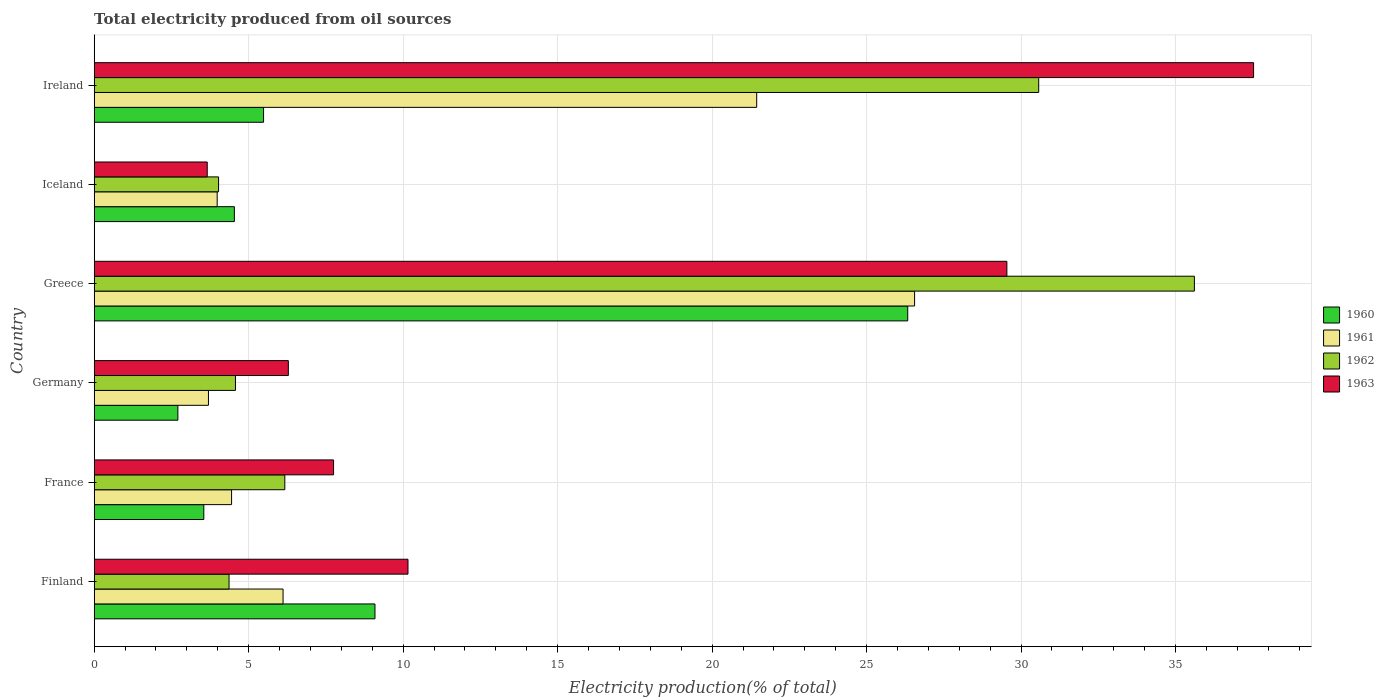How many different coloured bars are there?
Ensure brevity in your answer.  4. Are the number of bars per tick equal to the number of legend labels?
Your response must be concise. Yes. In how many cases, is the number of bars for a given country not equal to the number of legend labels?
Give a very brief answer. 0. What is the total electricity produced in 1960 in France?
Give a very brief answer. 3.55. Across all countries, what is the maximum total electricity produced in 1960?
Keep it short and to the point. 26.33. Across all countries, what is the minimum total electricity produced in 1963?
Provide a short and direct response. 3.66. In which country was the total electricity produced in 1961 maximum?
Provide a succinct answer. Greece. In which country was the total electricity produced in 1963 minimum?
Make the answer very short. Iceland. What is the total total electricity produced in 1961 in the graph?
Give a very brief answer. 66.23. What is the difference between the total electricity produced in 1963 in Finland and that in Iceland?
Provide a succinct answer. 6.5. What is the difference between the total electricity produced in 1962 in Greece and the total electricity produced in 1961 in Germany?
Keep it short and to the point. 31.91. What is the average total electricity produced in 1963 per country?
Make the answer very short. 15.82. What is the difference between the total electricity produced in 1960 and total electricity produced in 1961 in Greece?
Ensure brevity in your answer.  -0.22. What is the ratio of the total electricity produced in 1963 in Finland to that in Germany?
Your answer should be compact. 1.62. What is the difference between the highest and the second highest total electricity produced in 1963?
Ensure brevity in your answer.  7.99. What is the difference between the highest and the lowest total electricity produced in 1962?
Give a very brief answer. 31.58. Is the sum of the total electricity produced in 1962 in Finland and Ireland greater than the maximum total electricity produced in 1963 across all countries?
Offer a very short reply. No. What does the 4th bar from the top in France represents?
Your answer should be compact. 1960. What does the 1st bar from the bottom in France represents?
Your answer should be compact. 1960. Are all the bars in the graph horizontal?
Provide a short and direct response. Yes. How many countries are there in the graph?
Your response must be concise. 6. Where does the legend appear in the graph?
Keep it short and to the point. Center right. How many legend labels are there?
Your response must be concise. 4. How are the legend labels stacked?
Offer a terse response. Vertical. What is the title of the graph?
Offer a terse response. Total electricity produced from oil sources. What is the label or title of the Y-axis?
Make the answer very short. Country. What is the Electricity production(% of total) of 1960 in Finland?
Ensure brevity in your answer.  9.09. What is the Electricity production(% of total) in 1961 in Finland?
Offer a very short reply. 6.11. What is the Electricity production(% of total) in 1962 in Finland?
Give a very brief answer. 4.36. What is the Electricity production(% of total) of 1963 in Finland?
Ensure brevity in your answer.  10.16. What is the Electricity production(% of total) in 1960 in France?
Provide a short and direct response. 3.55. What is the Electricity production(% of total) in 1961 in France?
Offer a very short reply. 4.45. What is the Electricity production(% of total) in 1962 in France?
Ensure brevity in your answer.  6.17. What is the Electricity production(% of total) of 1963 in France?
Your response must be concise. 7.75. What is the Electricity production(% of total) of 1960 in Germany?
Make the answer very short. 2.71. What is the Electricity production(% of total) in 1961 in Germany?
Give a very brief answer. 3.7. What is the Electricity production(% of total) in 1962 in Germany?
Keep it short and to the point. 4.57. What is the Electricity production(% of total) in 1963 in Germany?
Offer a terse response. 6.28. What is the Electricity production(% of total) in 1960 in Greece?
Provide a succinct answer. 26.33. What is the Electricity production(% of total) in 1961 in Greece?
Your answer should be very brief. 26.55. What is the Electricity production(% of total) in 1962 in Greece?
Provide a succinct answer. 35.61. What is the Electricity production(% of total) of 1963 in Greece?
Keep it short and to the point. 29.54. What is the Electricity production(% of total) of 1960 in Iceland?
Your answer should be very brief. 4.54. What is the Electricity production(% of total) of 1961 in Iceland?
Ensure brevity in your answer.  3.98. What is the Electricity production(% of total) in 1962 in Iceland?
Provide a short and direct response. 4.03. What is the Electricity production(% of total) in 1963 in Iceland?
Your response must be concise. 3.66. What is the Electricity production(% of total) of 1960 in Ireland?
Your answer should be compact. 5.48. What is the Electricity production(% of total) in 1961 in Ireland?
Provide a short and direct response. 21.44. What is the Electricity production(% of total) of 1962 in Ireland?
Keep it short and to the point. 30.57. What is the Electricity production(% of total) of 1963 in Ireland?
Provide a succinct answer. 37.53. Across all countries, what is the maximum Electricity production(% of total) of 1960?
Offer a very short reply. 26.33. Across all countries, what is the maximum Electricity production(% of total) in 1961?
Offer a very short reply. 26.55. Across all countries, what is the maximum Electricity production(% of total) in 1962?
Make the answer very short. 35.61. Across all countries, what is the maximum Electricity production(% of total) of 1963?
Offer a terse response. 37.53. Across all countries, what is the minimum Electricity production(% of total) of 1960?
Provide a short and direct response. 2.71. Across all countries, what is the minimum Electricity production(% of total) in 1961?
Make the answer very short. 3.7. Across all countries, what is the minimum Electricity production(% of total) of 1962?
Your response must be concise. 4.03. Across all countries, what is the minimum Electricity production(% of total) in 1963?
Keep it short and to the point. 3.66. What is the total Electricity production(% of total) in 1960 in the graph?
Provide a short and direct response. 51.7. What is the total Electricity production(% of total) in 1961 in the graph?
Your answer should be very brief. 66.23. What is the total Electricity production(% of total) in 1962 in the graph?
Give a very brief answer. 85.31. What is the total Electricity production(% of total) of 1963 in the graph?
Your answer should be compact. 94.91. What is the difference between the Electricity production(% of total) in 1960 in Finland and that in France?
Keep it short and to the point. 5.54. What is the difference between the Electricity production(% of total) in 1961 in Finland and that in France?
Your response must be concise. 1.67. What is the difference between the Electricity production(% of total) in 1962 in Finland and that in France?
Your answer should be compact. -1.8. What is the difference between the Electricity production(% of total) in 1963 in Finland and that in France?
Offer a very short reply. 2.41. What is the difference between the Electricity production(% of total) in 1960 in Finland and that in Germany?
Offer a terse response. 6.38. What is the difference between the Electricity production(% of total) of 1961 in Finland and that in Germany?
Your response must be concise. 2.41. What is the difference between the Electricity production(% of total) of 1962 in Finland and that in Germany?
Ensure brevity in your answer.  -0.21. What is the difference between the Electricity production(% of total) in 1963 in Finland and that in Germany?
Ensure brevity in your answer.  3.87. What is the difference between the Electricity production(% of total) of 1960 in Finland and that in Greece?
Keep it short and to the point. -17.24. What is the difference between the Electricity production(% of total) in 1961 in Finland and that in Greece?
Offer a very short reply. -20.44. What is the difference between the Electricity production(% of total) in 1962 in Finland and that in Greece?
Your response must be concise. -31.25. What is the difference between the Electricity production(% of total) in 1963 in Finland and that in Greece?
Give a very brief answer. -19.38. What is the difference between the Electricity production(% of total) in 1960 in Finland and that in Iceland?
Your answer should be compact. 4.55. What is the difference between the Electricity production(% of total) in 1961 in Finland and that in Iceland?
Give a very brief answer. 2.13. What is the difference between the Electricity production(% of total) in 1962 in Finland and that in Iceland?
Ensure brevity in your answer.  0.34. What is the difference between the Electricity production(% of total) in 1963 in Finland and that in Iceland?
Offer a terse response. 6.5. What is the difference between the Electricity production(% of total) of 1960 in Finland and that in Ireland?
Ensure brevity in your answer.  3.61. What is the difference between the Electricity production(% of total) of 1961 in Finland and that in Ireland?
Make the answer very short. -15.33. What is the difference between the Electricity production(% of total) of 1962 in Finland and that in Ireland?
Ensure brevity in your answer.  -26.21. What is the difference between the Electricity production(% of total) of 1963 in Finland and that in Ireland?
Provide a short and direct response. -27.37. What is the difference between the Electricity production(% of total) in 1960 in France and that in Germany?
Your answer should be very brief. 0.84. What is the difference between the Electricity production(% of total) in 1961 in France and that in Germany?
Your response must be concise. 0.75. What is the difference between the Electricity production(% of total) in 1962 in France and that in Germany?
Your answer should be very brief. 1.6. What is the difference between the Electricity production(% of total) of 1963 in France and that in Germany?
Provide a succinct answer. 1.46. What is the difference between the Electricity production(% of total) of 1960 in France and that in Greece?
Your answer should be very brief. -22.78. What is the difference between the Electricity production(% of total) in 1961 in France and that in Greece?
Your response must be concise. -22.11. What is the difference between the Electricity production(% of total) of 1962 in France and that in Greece?
Offer a very short reply. -29.44. What is the difference between the Electricity production(% of total) in 1963 in France and that in Greece?
Keep it short and to the point. -21.79. What is the difference between the Electricity production(% of total) in 1960 in France and that in Iceland?
Provide a short and direct response. -0.99. What is the difference between the Electricity production(% of total) in 1961 in France and that in Iceland?
Offer a very short reply. 0.47. What is the difference between the Electricity production(% of total) in 1962 in France and that in Iceland?
Offer a terse response. 2.14. What is the difference between the Electricity production(% of total) in 1963 in France and that in Iceland?
Your response must be concise. 4.09. What is the difference between the Electricity production(% of total) of 1960 in France and that in Ireland?
Your answer should be very brief. -1.93. What is the difference between the Electricity production(% of total) of 1961 in France and that in Ireland?
Your answer should be compact. -17. What is the difference between the Electricity production(% of total) in 1962 in France and that in Ireland?
Your answer should be very brief. -24.4. What is the difference between the Electricity production(% of total) in 1963 in France and that in Ireland?
Give a very brief answer. -29.78. What is the difference between the Electricity production(% of total) in 1960 in Germany and that in Greece?
Provide a succinct answer. -23.62. What is the difference between the Electricity production(% of total) in 1961 in Germany and that in Greece?
Ensure brevity in your answer.  -22.86. What is the difference between the Electricity production(% of total) of 1962 in Germany and that in Greece?
Your answer should be very brief. -31.04. What is the difference between the Electricity production(% of total) in 1963 in Germany and that in Greece?
Offer a terse response. -23.26. What is the difference between the Electricity production(% of total) in 1960 in Germany and that in Iceland?
Offer a terse response. -1.83. What is the difference between the Electricity production(% of total) of 1961 in Germany and that in Iceland?
Your answer should be very brief. -0.28. What is the difference between the Electricity production(% of total) of 1962 in Germany and that in Iceland?
Ensure brevity in your answer.  0.55. What is the difference between the Electricity production(% of total) of 1963 in Germany and that in Iceland?
Your response must be concise. 2.63. What is the difference between the Electricity production(% of total) in 1960 in Germany and that in Ireland?
Your answer should be very brief. -2.77. What is the difference between the Electricity production(% of total) of 1961 in Germany and that in Ireland?
Give a very brief answer. -17.75. What is the difference between the Electricity production(% of total) in 1962 in Germany and that in Ireland?
Offer a terse response. -26. What is the difference between the Electricity production(% of total) of 1963 in Germany and that in Ireland?
Offer a very short reply. -31.24. What is the difference between the Electricity production(% of total) of 1960 in Greece and that in Iceland?
Make the answer very short. 21.79. What is the difference between the Electricity production(% of total) in 1961 in Greece and that in Iceland?
Your answer should be compact. 22.57. What is the difference between the Electricity production(% of total) of 1962 in Greece and that in Iceland?
Offer a terse response. 31.58. What is the difference between the Electricity production(% of total) of 1963 in Greece and that in Iceland?
Offer a very short reply. 25.88. What is the difference between the Electricity production(% of total) of 1960 in Greece and that in Ireland?
Your response must be concise. 20.85. What is the difference between the Electricity production(% of total) of 1961 in Greece and that in Ireland?
Your answer should be very brief. 5.11. What is the difference between the Electricity production(% of total) in 1962 in Greece and that in Ireland?
Ensure brevity in your answer.  5.04. What is the difference between the Electricity production(% of total) in 1963 in Greece and that in Ireland?
Make the answer very short. -7.99. What is the difference between the Electricity production(% of total) of 1960 in Iceland and that in Ireland?
Make the answer very short. -0.94. What is the difference between the Electricity production(% of total) in 1961 in Iceland and that in Ireland?
Offer a very short reply. -17.46. What is the difference between the Electricity production(% of total) of 1962 in Iceland and that in Ireland?
Keep it short and to the point. -26.55. What is the difference between the Electricity production(% of total) in 1963 in Iceland and that in Ireland?
Your answer should be very brief. -33.87. What is the difference between the Electricity production(% of total) in 1960 in Finland and the Electricity production(% of total) in 1961 in France?
Your response must be concise. 4.64. What is the difference between the Electricity production(% of total) in 1960 in Finland and the Electricity production(% of total) in 1962 in France?
Offer a terse response. 2.92. What is the difference between the Electricity production(% of total) of 1960 in Finland and the Electricity production(% of total) of 1963 in France?
Keep it short and to the point. 1.34. What is the difference between the Electricity production(% of total) of 1961 in Finland and the Electricity production(% of total) of 1962 in France?
Offer a very short reply. -0.06. What is the difference between the Electricity production(% of total) in 1961 in Finland and the Electricity production(% of total) in 1963 in France?
Give a very brief answer. -1.64. What is the difference between the Electricity production(% of total) in 1962 in Finland and the Electricity production(% of total) in 1963 in France?
Your answer should be compact. -3.38. What is the difference between the Electricity production(% of total) of 1960 in Finland and the Electricity production(% of total) of 1961 in Germany?
Make the answer very short. 5.39. What is the difference between the Electricity production(% of total) of 1960 in Finland and the Electricity production(% of total) of 1962 in Germany?
Provide a short and direct response. 4.51. What is the difference between the Electricity production(% of total) of 1960 in Finland and the Electricity production(% of total) of 1963 in Germany?
Keep it short and to the point. 2.8. What is the difference between the Electricity production(% of total) of 1961 in Finland and the Electricity production(% of total) of 1962 in Germany?
Offer a very short reply. 1.54. What is the difference between the Electricity production(% of total) of 1961 in Finland and the Electricity production(% of total) of 1963 in Germany?
Offer a very short reply. -0.17. What is the difference between the Electricity production(% of total) in 1962 in Finland and the Electricity production(% of total) in 1963 in Germany?
Offer a very short reply. -1.92. What is the difference between the Electricity production(% of total) of 1960 in Finland and the Electricity production(% of total) of 1961 in Greece?
Offer a very short reply. -17.47. What is the difference between the Electricity production(% of total) of 1960 in Finland and the Electricity production(% of total) of 1962 in Greece?
Your answer should be very brief. -26.52. What is the difference between the Electricity production(% of total) of 1960 in Finland and the Electricity production(% of total) of 1963 in Greece?
Provide a short and direct response. -20.45. What is the difference between the Electricity production(% of total) in 1961 in Finland and the Electricity production(% of total) in 1962 in Greece?
Offer a terse response. -29.5. What is the difference between the Electricity production(% of total) in 1961 in Finland and the Electricity production(% of total) in 1963 in Greece?
Your answer should be compact. -23.43. What is the difference between the Electricity production(% of total) of 1962 in Finland and the Electricity production(% of total) of 1963 in Greece?
Ensure brevity in your answer.  -25.18. What is the difference between the Electricity production(% of total) of 1960 in Finland and the Electricity production(% of total) of 1961 in Iceland?
Give a very brief answer. 5.11. What is the difference between the Electricity production(% of total) in 1960 in Finland and the Electricity production(% of total) in 1962 in Iceland?
Your answer should be compact. 5.06. What is the difference between the Electricity production(% of total) in 1960 in Finland and the Electricity production(% of total) in 1963 in Iceland?
Your answer should be compact. 5.43. What is the difference between the Electricity production(% of total) in 1961 in Finland and the Electricity production(% of total) in 1962 in Iceland?
Keep it short and to the point. 2.09. What is the difference between the Electricity production(% of total) in 1961 in Finland and the Electricity production(% of total) in 1963 in Iceland?
Provide a succinct answer. 2.45. What is the difference between the Electricity production(% of total) in 1962 in Finland and the Electricity production(% of total) in 1963 in Iceland?
Offer a very short reply. 0.71. What is the difference between the Electricity production(% of total) in 1960 in Finland and the Electricity production(% of total) in 1961 in Ireland?
Ensure brevity in your answer.  -12.36. What is the difference between the Electricity production(% of total) of 1960 in Finland and the Electricity production(% of total) of 1962 in Ireland?
Offer a very short reply. -21.48. What is the difference between the Electricity production(% of total) of 1960 in Finland and the Electricity production(% of total) of 1963 in Ireland?
Offer a terse response. -28.44. What is the difference between the Electricity production(% of total) in 1961 in Finland and the Electricity production(% of total) in 1962 in Ireland?
Offer a terse response. -24.46. What is the difference between the Electricity production(% of total) of 1961 in Finland and the Electricity production(% of total) of 1963 in Ireland?
Offer a very short reply. -31.41. What is the difference between the Electricity production(% of total) of 1962 in Finland and the Electricity production(% of total) of 1963 in Ireland?
Give a very brief answer. -33.16. What is the difference between the Electricity production(% of total) of 1960 in France and the Electricity production(% of total) of 1961 in Germany?
Ensure brevity in your answer.  -0.15. What is the difference between the Electricity production(% of total) of 1960 in France and the Electricity production(% of total) of 1962 in Germany?
Your answer should be compact. -1.02. What is the difference between the Electricity production(% of total) in 1960 in France and the Electricity production(% of total) in 1963 in Germany?
Provide a short and direct response. -2.74. What is the difference between the Electricity production(% of total) in 1961 in France and the Electricity production(% of total) in 1962 in Germany?
Offer a terse response. -0.13. What is the difference between the Electricity production(% of total) of 1961 in France and the Electricity production(% of total) of 1963 in Germany?
Make the answer very short. -1.84. What is the difference between the Electricity production(% of total) of 1962 in France and the Electricity production(% of total) of 1963 in Germany?
Your response must be concise. -0.11. What is the difference between the Electricity production(% of total) in 1960 in France and the Electricity production(% of total) in 1961 in Greece?
Your answer should be compact. -23.01. What is the difference between the Electricity production(% of total) of 1960 in France and the Electricity production(% of total) of 1962 in Greece?
Provide a short and direct response. -32.06. What is the difference between the Electricity production(% of total) of 1960 in France and the Electricity production(% of total) of 1963 in Greece?
Keep it short and to the point. -25.99. What is the difference between the Electricity production(% of total) in 1961 in France and the Electricity production(% of total) in 1962 in Greece?
Offer a terse response. -31.16. What is the difference between the Electricity production(% of total) in 1961 in France and the Electricity production(% of total) in 1963 in Greece?
Provide a short and direct response. -25.09. What is the difference between the Electricity production(% of total) of 1962 in France and the Electricity production(% of total) of 1963 in Greece?
Provide a succinct answer. -23.37. What is the difference between the Electricity production(% of total) of 1960 in France and the Electricity production(% of total) of 1961 in Iceland?
Offer a very short reply. -0.43. What is the difference between the Electricity production(% of total) of 1960 in France and the Electricity production(% of total) of 1962 in Iceland?
Ensure brevity in your answer.  -0.48. What is the difference between the Electricity production(% of total) of 1960 in France and the Electricity production(% of total) of 1963 in Iceland?
Your answer should be compact. -0.11. What is the difference between the Electricity production(% of total) of 1961 in France and the Electricity production(% of total) of 1962 in Iceland?
Keep it short and to the point. 0.42. What is the difference between the Electricity production(% of total) of 1961 in France and the Electricity production(% of total) of 1963 in Iceland?
Ensure brevity in your answer.  0.79. What is the difference between the Electricity production(% of total) of 1962 in France and the Electricity production(% of total) of 1963 in Iceland?
Make the answer very short. 2.51. What is the difference between the Electricity production(% of total) in 1960 in France and the Electricity production(% of total) in 1961 in Ireland?
Give a very brief answer. -17.9. What is the difference between the Electricity production(% of total) of 1960 in France and the Electricity production(% of total) of 1962 in Ireland?
Offer a terse response. -27.02. What is the difference between the Electricity production(% of total) in 1960 in France and the Electricity production(% of total) in 1963 in Ireland?
Keep it short and to the point. -33.98. What is the difference between the Electricity production(% of total) of 1961 in France and the Electricity production(% of total) of 1962 in Ireland?
Provide a short and direct response. -26.12. What is the difference between the Electricity production(% of total) in 1961 in France and the Electricity production(% of total) in 1963 in Ireland?
Your answer should be very brief. -33.08. What is the difference between the Electricity production(% of total) of 1962 in France and the Electricity production(% of total) of 1963 in Ireland?
Offer a very short reply. -31.36. What is the difference between the Electricity production(% of total) of 1960 in Germany and the Electricity production(% of total) of 1961 in Greece?
Keep it short and to the point. -23.85. What is the difference between the Electricity production(% of total) of 1960 in Germany and the Electricity production(% of total) of 1962 in Greece?
Your answer should be very brief. -32.9. What is the difference between the Electricity production(% of total) of 1960 in Germany and the Electricity production(% of total) of 1963 in Greece?
Your answer should be very brief. -26.83. What is the difference between the Electricity production(% of total) in 1961 in Germany and the Electricity production(% of total) in 1962 in Greece?
Your answer should be very brief. -31.91. What is the difference between the Electricity production(% of total) of 1961 in Germany and the Electricity production(% of total) of 1963 in Greece?
Give a very brief answer. -25.84. What is the difference between the Electricity production(% of total) of 1962 in Germany and the Electricity production(% of total) of 1963 in Greece?
Make the answer very short. -24.97. What is the difference between the Electricity production(% of total) of 1960 in Germany and the Electricity production(% of total) of 1961 in Iceland?
Your answer should be very brief. -1.27. What is the difference between the Electricity production(% of total) in 1960 in Germany and the Electricity production(% of total) in 1962 in Iceland?
Provide a short and direct response. -1.32. What is the difference between the Electricity production(% of total) of 1960 in Germany and the Electricity production(% of total) of 1963 in Iceland?
Provide a succinct answer. -0.95. What is the difference between the Electricity production(% of total) in 1961 in Germany and the Electricity production(% of total) in 1962 in Iceland?
Offer a very short reply. -0.33. What is the difference between the Electricity production(% of total) of 1961 in Germany and the Electricity production(% of total) of 1963 in Iceland?
Make the answer very short. 0.04. What is the difference between the Electricity production(% of total) of 1962 in Germany and the Electricity production(% of total) of 1963 in Iceland?
Provide a succinct answer. 0.91. What is the difference between the Electricity production(% of total) in 1960 in Germany and the Electricity production(% of total) in 1961 in Ireland?
Offer a very short reply. -18.73. What is the difference between the Electricity production(% of total) of 1960 in Germany and the Electricity production(% of total) of 1962 in Ireland?
Offer a terse response. -27.86. What is the difference between the Electricity production(% of total) in 1960 in Germany and the Electricity production(% of total) in 1963 in Ireland?
Keep it short and to the point. -34.82. What is the difference between the Electricity production(% of total) in 1961 in Germany and the Electricity production(% of total) in 1962 in Ireland?
Provide a short and direct response. -26.87. What is the difference between the Electricity production(% of total) of 1961 in Germany and the Electricity production(% of total) of 1963 in Ireland?
Offer a very short reply. -33.83. What is the difference between the Electricity production(% of total) of 1962 in Germany and the Electricity production(% of total) of 1963 in Ireland?
Provide a short and direct response. -32.95. What is the difference between the Electricity production(% of total) in 1960 in Greece and the Electricity production(% of total) in 1961 in Iceland?
Your answer should be compact. 22.35. What is the difference between the Electricity production(% of total) of 1960 in Greece and the Electricity production(% of total) of 1962 in Iceland?
Offer a terse response. 22.31. What is the difference between the Electricity production(% of total) of 1960 in Greece and the Electricity production(% of total) of 1963 in Iceland?
Offer a terse response. 22.67. What is the difference between the Electricity production(% of total) of 1961 in Greece and the Electricity production(% of total) of 1962 in Iceland?
Give a very brief answer. 22.53. What is the difference between the Electricity production(% of total) of 1961 in Greece and the Electricity production(% of total) of 1963 in Iceland?
Your response must be concise. 22.9. What is the difference between the Electricity production(% of total) in 1962 in Greece and the Electricity production(% of total) in 1963 in Iceland?
Your answer should be very brief. 31.95. What is the difference between the Electricity production(% of total) in 1960 in Greece and the Electricity production(% of total) in 1961 in Ireland?
Provide a short and direct response. 4.89. What is the difference between the Electricity production(% of total) of 1960 in Greece and the Electricity production(% of total) of 1962 in Ireland?
Your answer should be compact. -4.24. What is the difference between the Electricity production(% of total) in 1960 in Greece and the Electricity production(% of total) in 1963 in Ireland?
Make the answer very short. -11.19. What is the difference between the Electricity production(% of total) of 1961 in Greece and the Electricity production(% of total) of 1962 in Ireland?
Offer a terse response. -4.02. What is the difference between the Electricity production(% of total) in 1961 in Greece and the Electricity production(% of total) in 1963 in Ireland?
Provide a short and direct response. -10.97. What is the difference between the Electricity production(% of total) of 1962 in Greece and the Electricity production(% of total) of 1963 in Ireland?
Offer a very short reply. -1.92. What is the difference between the Electricity production(% of total) in 1960 in Iceland and the Electricity production(% of total) in 1961 in Ireland?
Your answer should be compact. -16.91. What is the difference between the Electricity production(% of total) in 1960 in Iceland and the Electricity production(% of total) in 1962 in Ireland?
Your answer should be very brief. -26.03. What is the difference between the Electricity production(% of total) in 1960 in Iceland and the Electricity production(% of total) in 1963 in Ireland?
Offer a terse response. -32.99. What is the difference between the Electricity production(% of total) of 1961 in Iceland and the Electricity production(% of total) of 1962 in Ireland?
Your answer should be very brief. -26.59. What is the difference between the Electricity production(% of total) in 1961 in Iceland and the Electricity production(% of total) in 1963 in Ireland?
Make the answer very short. -33.55. What is the difference between the Electricity production(% of total) in 1962 in Iceland and the Electricity production(% of total) in 1963 in Ireland?
Your response must be concise. -33.5. What is the average Electricity production(% of total) of 1960 per country?
Make the answer very short. 8.62. What is the average Electricity production(% of total) of 1961 per country?
Make the answer very short. 11.04. What is the average Electricity production(% of total) of 1962 per country?
Keep it short and to the point. 14.22. What is the average Electricity production(% of total) of 1963 per country?
Make the answer very short. 15.82. What is the difference between the Electricity production(% of total) in 1960 and Electricity production(% of total) in 1961 in Finland?
Provide a short and direct response. 2.98. What is the difference between the Electricity production(% of total) in 1960 and Electricity production(% of total) in 1962 in Finland?
Provide a succinct answer. 4.72. What is the difference between the Electricity production(% of total) in 1960 and Electricity production(% of total) in 1963 in Finland?
Ensure brevity in your answer.  -1.07. What is the difference between the Electricity production(% of total) in 1961 and Electricity production(% of total) in 1962 in Finland?
Offer a very short reply. 1.75. What is the difference between the Electricity production(% of total) in 1961 and Electricity production(% of total) in 1963 in Finland?
Your answer should be compact. -4.04. What is the difference between the Electricity production(% of total) in 1962 and Electricity production(% of total) in 1963 in Finland?
Provide a short and direct response. -5.79. What is the difference between the Electricity production(% of total) in 1960 and Electricity production(% of total) in 1961 in France?
Ensure brevity in your answer.  -0.9. What is the difference between the Electricity production(% of total) in 1960 and Electricity production(% of total) in 1962 in France?
Provide a short and direct response. -2.62. What is the difference between the Electricity production(% of total) of 1960 and Electricity production(% of total) of 1963 in France?
Provide a succinct answer. -4.2. What is the difference between the Electricity production(% of total) in 1961 and Electricity production(% of total) in 1962 in France?
Offer a very short reply. -1.72. What is the difference between the Electricity production(% of total) of 1961 and Electricity production(% of total) of 1963 in France?
Offer a very short reply. -3.3. What is the difference between the Electricity production(% of total) in 1962 and Electricity production(% of total) in 1963 in France?
Make the answer very short. -1.58. What is the difference between the Electricity production(% of total) of 1960 and Electricity production(% of total) of 1961 in Germany?
Your response must be concise. -0.99. What is the difference between the Electricity production(% of total) in 1960 and Electricity production(% of total) in 1962 in Germany?
Make the answer very short. -1.86. What is the difference between the Electricity production(% of total) of 1960 and Electricity production(% of total) of 1963 in Germany?
Provide a succinct answer. -3.58. What is the difference between the Electricity production(% of total) in 1961 and Electricity production(% of total) in 1962 in Germany?
Make the answer very short. -0.87. What is the difference between the Electricity production(% of total) of 1961 and Electricity production(% of total) of 1963 in Germany?
Ensure brevity in your answer.  -2.59. What is the difference between the Electricity production(% of total) in 1962 and Electricity production(% of total) in 1963 in Germany?
Your answer should be compact. -1.71. What is the difference between the Electricity production(% of total) of 1960 and Electricity production(% of total) of 1961 in Greece?
Offer a very short reply. -0.22. What is the difference between the Electricity production(% of total) of 1960 and Electricity production(% of total) of 1962 in Greece?
Your response must be concise. -9.28. What is the difference between the Electricity production(% of total) of 1960 and Electricity production(% of total) of 1963 in Greece?
Offer a terse response. -3.21. What is the difference between the Electricity production(% of total) of 1961 and Electricity production(% of total) of 1962 in Greece?
Your response must be concise. -9.06. What is the difference between the Electricity production(% of total) in 1961 and Electricity production(% of total) in 1963 in Greece?
Your answer should be very brief. -2.99. What is the difference between the Electricity production(% of total) of 1962 and Electricity production(% of total) of 1963 in Greece?
Your answer should be very brief. 6.07. What is the difference between the Electricity production(% of total) of 1960 and Electricity production(% of total) of 1961 in Iceland?
Provide a succinct answer. 0.56. What is the difference between the Electricity production(% of total) in 1960 and Electricity production(% of total) in 1962 in Iceland?
Your answer should be very brief. 0.51. What is the difference between the Electricity production(% of total) in 1960 and Electricity production(% of total) in 1963 in Iceland?
Your response must be concise. 0.88. What is the difference between the Electricity production(% of total) in 1961 and Electricity production(% of total) in 1962 in Iceland?
Ensure brevity in your answer.  -0.05. What is the difference between the Electricity production(% of total) in 1961 and Electricity production(% of total) in 1963 in Iceland?
Your response must be concise. 0.32. What is the difference between the Electricity production(% of total) of 1962 and Electricity production(% of total) of 1963 in Iceland?
Provide a succinct answer. 0.37. What is the difference between the Electricity production(% of total) in 1960 and Electricity production(% of total) in 1961 in Ireland?
Your answer should be compact. -15.96. What is the difference between the Electricity production(% of total) of 1960 and Electricity production(% of total) of 1962 in Ireland?
Provide a short and direct response. -25.09. What is the difference between the Electricity production(% of total) of 1960 and Electricity production(% of total) of 1963 in Ireland?
Offer a very short reply. -32.04. What is the difference between the Electricity production(% of total) of 1961 and Electricity production(% of total) of 1962 in Ireland?
Your answer should be very brief. -9.13. What is the difference between the Electricity production(% of total) in 1961 and Electricity production(% of total) in 1963 in Ireland?
Keep it short and to the point. -16.08. What is the difference between the Electricity production(% of total) in 1962 and Electricity production(% of total) in 1963 in Ireland?
Keep it short and to the point. -6.95. What is the ratio of the Electricity production(% of total) of 1960 in Finland to that in France?
Your response must be concise. 2.56. What is the ratio of the Electricity production(% of total) of 1961 in Finland to that in France?
Provide a short and direct response. 1.37. What is the ratio of the Electricity production(% of total) of 1962 in Finland to that in France?
Your answer should be very brief. 0.71. What is the ratio of the Electricity production(% of total) of 1963 in Finland to that in France?
Offer a very short reply. 1.31. What is the ratio of the Electricity production(% of total) of 1960 in Finland to that in Germany?
Ensure brevity in your answer.  3.36. What is the ratio of the Electricity production(% of total) in 1961 in Finland to that in Germany?
Provide a succinct answer. 1.65. What is the ratio of the Electricity production(% of total) of 1962 in Finland to that in Germany?
Your answer should be very brief. 0.95. What is the ratio of the Electricity production(% of total) in 1963 in Finland to that in Germany?
Give a very brief answer. 1.62. What is the ratio of the Electricity production(% of total) of 1960 in Finland to that in Greece?
Offer a terse response. 0.35. What is the ratio of the Electricity production(% of total) in 1961 in Finland to that in Greece?
Keep it short and to the point. 0.23. What is the ratio of the Electricity production(% of total) of 1962 in Finland to that in Greece?
Make the answer very short. 0.12. What is the ratio of the Electricity production(% of total) in 1963 in Finland to that in Greece?
Ensure brevity in your answer.  0.34. What is the ratio of the Electricity production(% of total) of 1960 in Finland to that in Iceland?
Offer a very short reply. 2. What is the ratio of the Electricity production(% of total) of 1961 in Finland to that in Iceland?
Your answer should be compact. 1.54. What is the ratio of the Electricity production(% of total) of 1962 in Finland to that in Iceland?
Ensure brevity in your answer.  1.08. What is the ratio of the Electricity production(% of total) of 1963 in Finland to that in Iceland?
Ensure brevity in your answer.  2.78. What is the ratio of the Electricity production(% of total) of 1960 in Finland to that in Ireland?
Provide a succinct answer. 1.66. What is the ratio of the Electricity production(% of total) of 1961 in Finland to that in Ireland?
Your response must be concise. 0.29. What is the ratio of the Electricity production(% of total) of 1962 in Finland to that in Ireland?
Your response must be concise. 0.14. What is the ratio of the Electricity production(% of total) of 1963 in Finland to that in Ireland?
Your answer should be compact. 0.27. What is the ratio of the Electricity production(% of total) in 1960 in France to that in Germany?
Your response must be concise. 1.31. What is the ratio of the Electricity production(% of total) of 1961 in France to that in Germany?
Offer a very short reply. 1.2. What is the ratio of the Electricity production(% of total) of 1962 in France to that in Germany?
Provide a short and direct response. 1.35. What is the ratio of the Electricity production(% of total) in 1963 in France to that in Germany?
Offer a terse response. 1.23. What is the ratio of the Electricity production(% of total) of 1960 in France to that in Greece?
Keep it short and to the point. 0.13. What is the ratio of the Electricity production(% of total) in 1961 in France to that in Greece?
Ensure brevity in your answer.  0.17. What is the ratio of the Electricity production(% of total) in 1962 in France to that in Greece?
Your answer should be very brief. 0.17. What is the ratio of the Electricity production(% of total) in 1963 in France to that in Greece?
Your answer should be compact. 0.26. What is the ratio of the Electricity production(% of total) in 1960 in France to that in Iceland?
Make the answer very short. 0.78. What is the ratio of the Electricity production(% of total) of 1961 in France to that in Iceland?
Give a very brief answer. 1.12. What is the ratio of the Electricity production(% of total) of 1962 in France to that in Iceland?
Provide a succinct answer. 1.53. What is the ratio of the Electricity production(% of total) in 1963 in France to that in Iceland?
Provide a short and direct response. 2.12. What is the ratio of the Electricity production(% of total) in 1960 in France to that in Ireland?
Give a very brief answer. 0.65. What is the ratio of the Electricity production(% of total) of 1961 in France to that in Ireland?
Offer a terse response. 0.21. What is the ratio of the Electricity production(% of total) of 1962 in France to that in Ireland?
Ensure brevity in your answer.  0.2. What is the ratio of the Electricity production(% of total) of 1963 in France to that in Ireland?
Provide a succinct answer. 0.21. What is the ratio of the Electricity production(% of total) in 1960 in Germany to that in Greece?
Provide a succinct answer. 0.1. What is the ratio of the Electricity production(% of total) in 1961 in Germany to that in Greece?
Provide a succinct answer. 0.14. What is the ratio of the Electricity production(% of total) of 1962 in Germany to that in Greece?
Offer a terse response. 0.13. What is the ratio of the Electricity production(% of total) in 1963 in Germany to that in Greece?
Ensure brevity in your answer.  0.21. What is the ratio of the Electricity production(% of total) in 1960 in Germany to that in Iceland?
Keep it short and to the point. 0.6. What is the ratio of the Electricity production(% of total) in 1961 in Germany to that in Iceland?
Offer a very short reply. 0.93. What is the ratio of the Electricity production(% of total) of 1962 in Germany to that in Iceland?
Ensure brevity in your answer.  1.14. What is the ratio of the Electricity production(% of total) of 1963 in Germany to that in Iceland?
Your response must be concise. 1.72. What is the ratio of the Electricity production(% of total) of 1960 in Germany to that in Ireland?
Your answer should be very brief. 0.49. What is the ratio of the Electricity production(% of total) in 1961 in Germany to that in Ireland?
Give a very brief answer. 0.17. What is the ratio of the Electricity production(% of total) of 1962 in Germany to that in Ireland?
Your response must be concise. 0.15. What is the ratio of the Electricity production(% of total) of 1963 in Germany to that in Ireland?
Keep it short and to the point. 0.17. What is the ratio of the Electricity production(% of total) in 1960 in Greece to that in Iceland?
Offer a terse response. 5.8. What is the ratio of the Electricity production(% of total) of 1961 in Greece to that in Iceland?
Give a very brief answer. 6.67. What is the ratio of the Electricity production(% of total) of 1962 in Greece to that in Iceland?
Make the answer very short. 8.85. What is the ratio of the Electricity production(% of total) in 1963 in Greece to that in Iceland?
Your answer should be compact. 8.07. What is the ratio of the Electricity production(% of total) in 1960 in Greece to that in Ireland?
Ensure brevity in your answer.  4.8. What is the ratio of the Electricity production(% of total) of 1961 in Greece to that in Ireland?
Provide a succinct answer. 1.24. What is the ratio of the Electricity production(% of total) of 1962 in Greece to that in Ireland?
Keep it short and to the point. 1.16. What is the ratio of the Electricity production(% of total) in 1963 in Greece to that in Ireland?
Your answer should be very brief. 0.79. What is the ratio of the Electricity production(% of total) in 1960 in Iceland to that in Ireland?
Give a very brief answer. 0.83. What is the ratio of the Electricity production(% of total) in 1961 in Iceland to that in Ireland?
Your answer should be very brief. 0.19. What is the ratio of the Electricity production(% of total) in 1962 in Iceland to that in Ireland?
Keep it short and to the point. 0.13. What is the ratio of the Electricity production(% of total) of 1963 in Iceland to that in Ireland?
Give a very brief answer. 0.1. What is the difference between the highest and the second highest Electricity production(% of total) of 1960?
Keep it short and to the point. 17.24. What is the difference between the highest and the second highest Electricity production(% of total) in 1961?
Ensure brevity in your answer.  5.11. What is the difference between the highest and the second highest Electricity production(% of total) in 1962?
Your response must be concise. 5.04. What is the difference between the highest and the second highest Electricity production(% of total) in 1963?
Give a very brief answer. 7.99. What is the difference between the highest and the lowest Electricity production(% of total) of 1960?
Your answer should be compact. 23.62. What is the difference between the highest and the lowest Electricity production(% of total) in 1961?
Offer a terse response. 22.86. What is the difference between the highest and the lowest Electricity production(% of total) in 1962?
Give a very brief answer. 31.58. What is the difference between the highest and the lowest Electricity production(% of total) in 1963?
Offer a terse response. 33.87. 